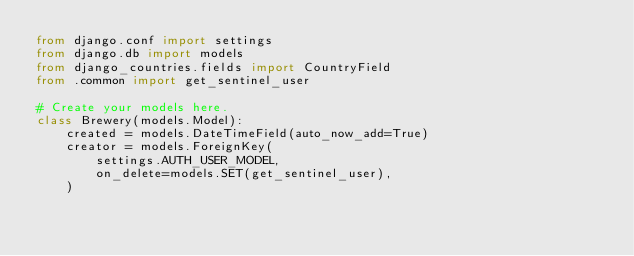Convert code to text. <code><loc_0><loc_0><loc_500><loc_500><_Python_>from django.conf import settings
from django.db import models
from django_countries.fields import CountryField
from .common import get_sentinel_user

# Create your models here.
class Brewery(models.Model):
    created = models.DateTimeField(auto_now_add=True)
    creator = models.ForeignKey(
        settings.AUTH_USER_MODEL,
        on_delete=models.SET(get_sentinel_user),
    )</code> 